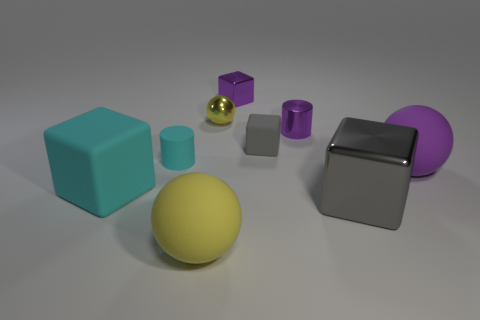What number of shiny objects are big green cylinders or purple cylinders?
Offer a terse response. 1. What is the color of the tiny cylinder that is made of the same material as the big yellow thing?
Give a very brief answer. Cyan. There is a large sphere on the right side of the small cube that is behind the small gray block; what is it made of?
Provide a succinct answer. Rubber. How many objects are either tiny purple things behind the small shiny cylinder or matte things in front of the cyan rubber block?
Offer a very short reply. 2. What is the size of the yellow thing right of the large matte ball that is on the left side of the matte ball that is on the right side of the small purple cylinder?
Your response must be concise. Small. Are there an equal number of rubber cylinders that are behind the small yellow sphere and metallic spheres?
Keep it short and to the point. No. Do the big cyan object and the object that is right of the big metallic object have the same shape?
Offer a very short reply. No. What size is the other yellow thing that is the same shape as the yellow metal object?
Offer a terse response. Large. What number of other objects are the same material as the large yellow thing?
Ensure brevity in your answer.  4. What is the material of the purple ball?
Offer a terse response. Rubber. 